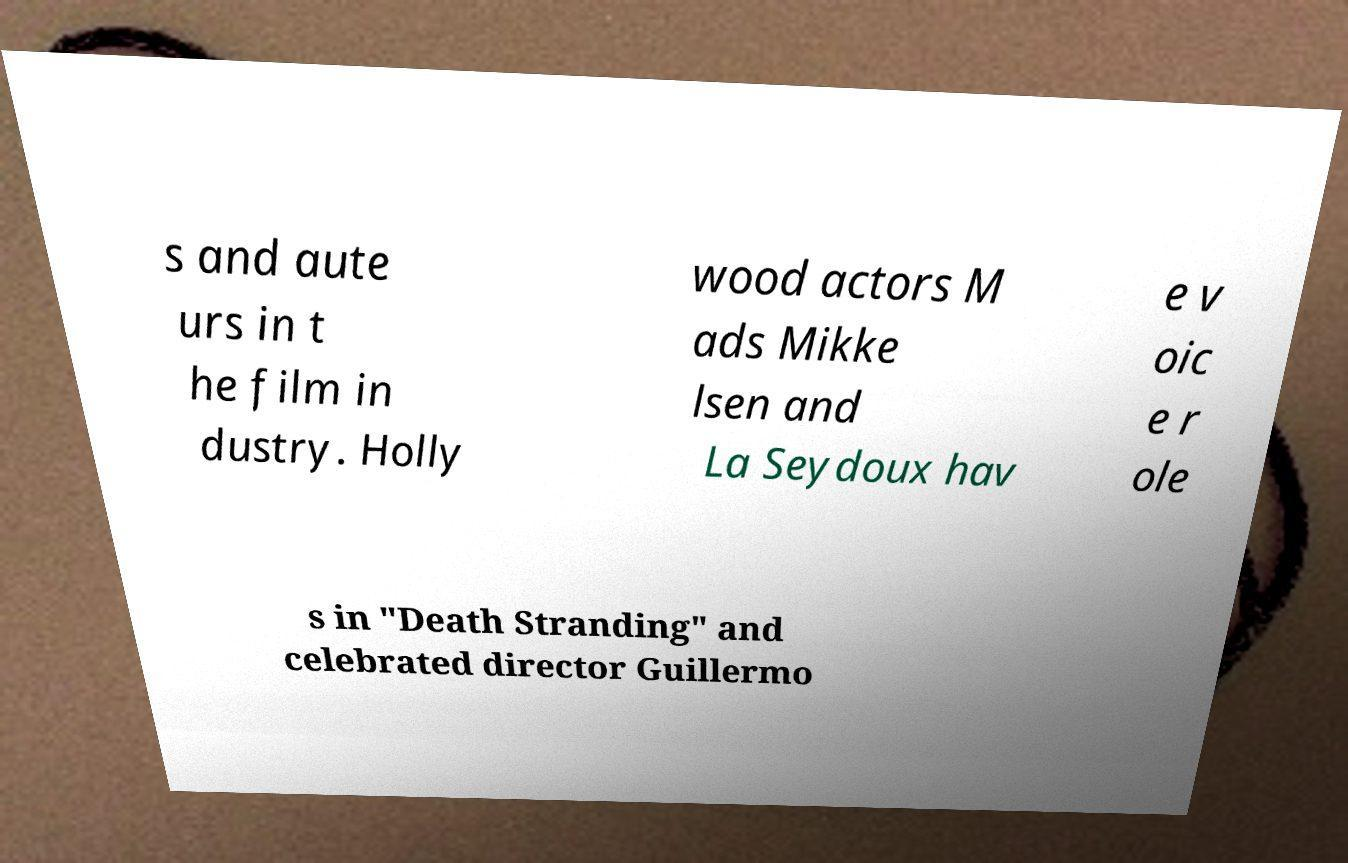Could you extract and type out the text from this image? s and aute urs in t he film in dustry. Holly wood actors M ads Mikke lsen and La Seydoux hav e v oic e r ole s in "Death Stranding" and celebrated director Guillermo 